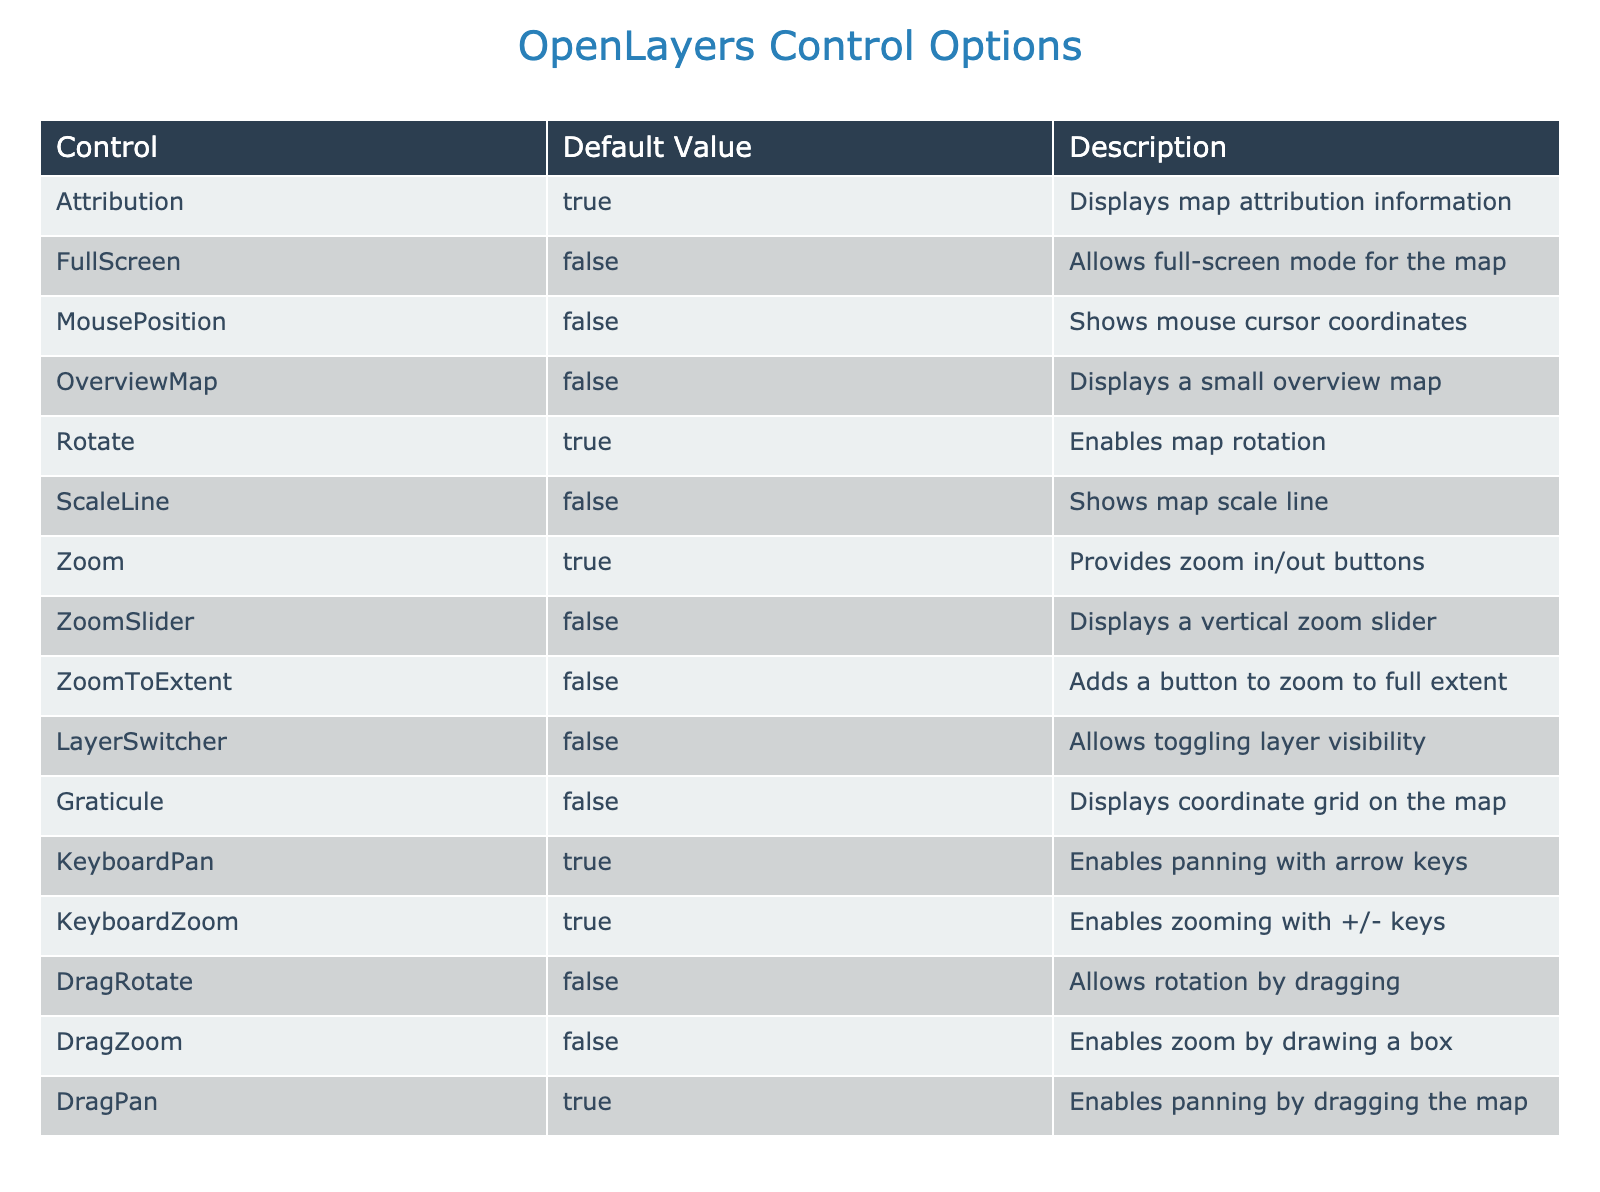What control option allows toggling layer visibility? The table lists "LayerSwitcher" as a control option, and the description indicates that it allows toggling layer visibility. Therefore, the answer is LayerSwitcher.
Answer: LayerSwitcher How many controls have a default value of true? By counting the rows in the table where the "Default Value" is true, we find that "Attribution", "Rotate", "KeyboardPan", "KeyboardZoom", and "Zoom" have a default value of true. There are 5 such controls.
Answer: 5 Does the MousePosition control option have a default value of true? Checking the "Default Value" for "MousePosition" in the table, it is listed as false, indicating that it does not have a default value of true.
Answer: No Which control options do not display a feature by default? The table lists several controls with a default value of false: "FullScreen", "MousePosition", "OverviewMap", "ScaleLine", "ZoomSlider", "ZoomToExtent", "LayerSwitcher", "Graticule", "DragRotate", and "DragZoom". Counting these gives a total of 9 control options that do not display a feature by default.
Answer: 9 What is the difference in the number of controls that enable panning by dragging versus those that enable zooming by drawing a box? From the table, "DragPan" allows panning by dragging, and "DragZoom" enables zoom by drawing a box. Both have a default value of true for "DragPan" and false for "DragZoom". Therefore, there is one control that enables panning by dragging and none for zooming by drawing a box, making the difference 1.
Answer: 1 